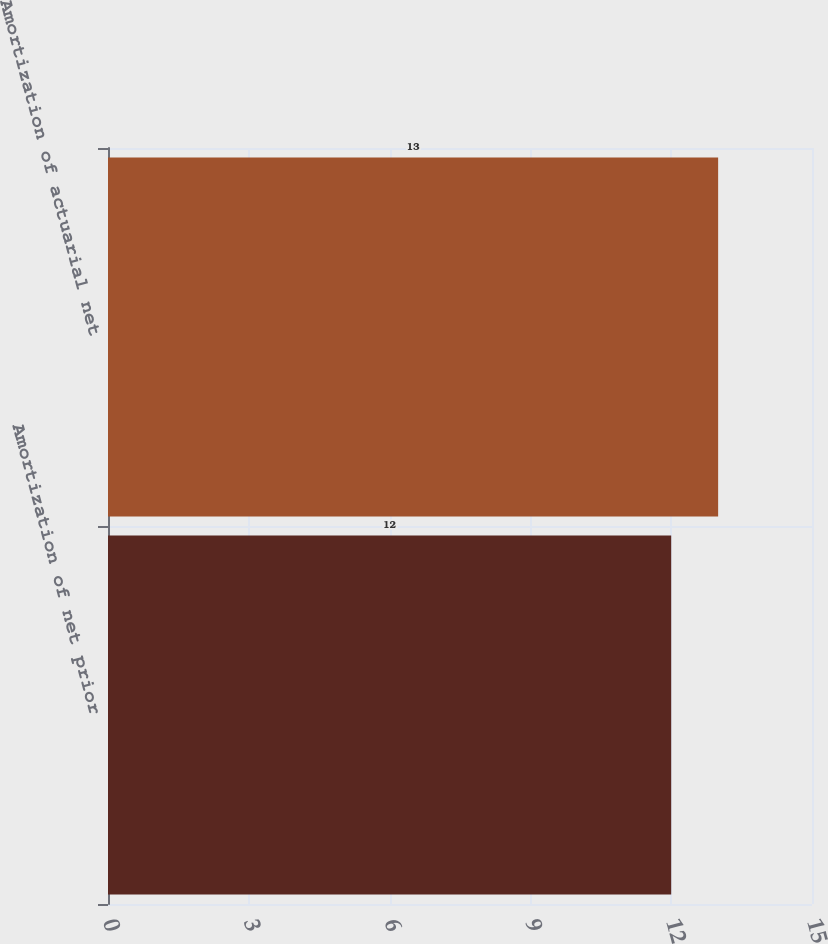Convert chart to OTSL. <chart><loc_0><loc_0><loc_500><loc_500><bar_chart><fcel>Amortization of net prior<fcel>Amortization of actuarial net<nl><fcel>12<fcel>13<nl></chart> 